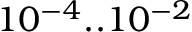<formula> <loc_0><loc_0><loc_500><loc_500>1 0 ^ { - 4 } . . 1 0 ^ { - 2 }</formula> 